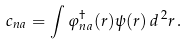Convert formula to latex. <formula><loc_0><loc_0><loc_500><loc_500>c _ { n a } = \int \varphi _ { n a } ^ { \dag } ( r ) \psi ( r ) \, d ^ { \, 2 } r \, .</formula> 